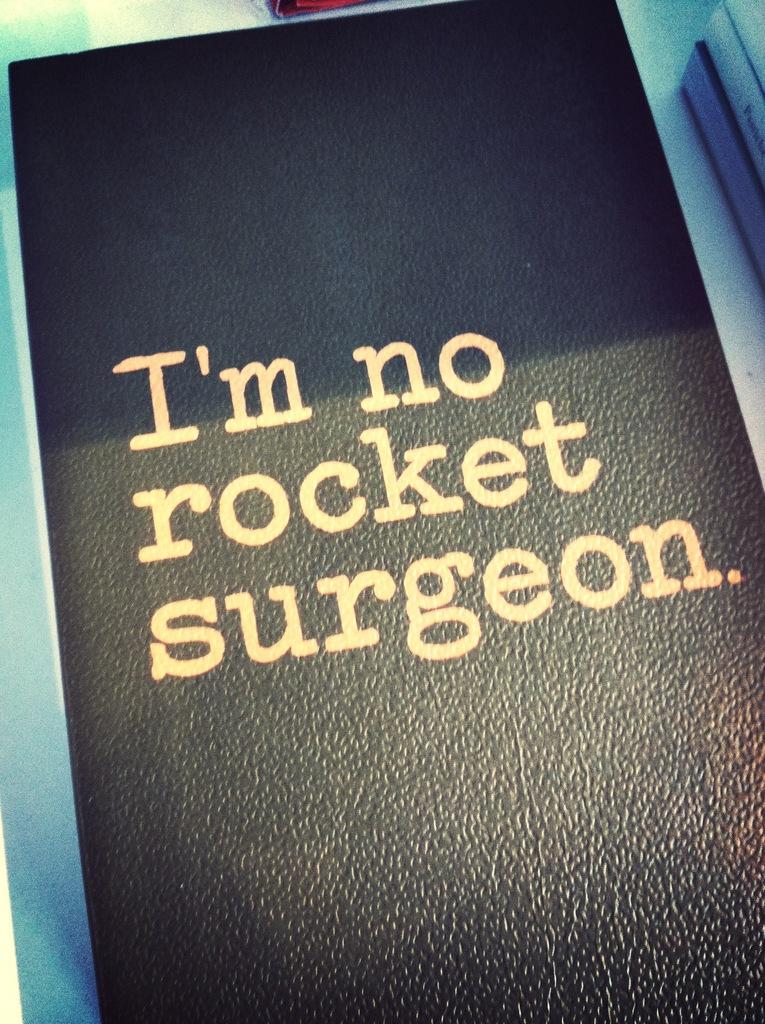What kind of surgeon are they not?
Keep it short and to the point. Rocket. What does this say?
Your response must be concise. I'm no rocket surgeon. 